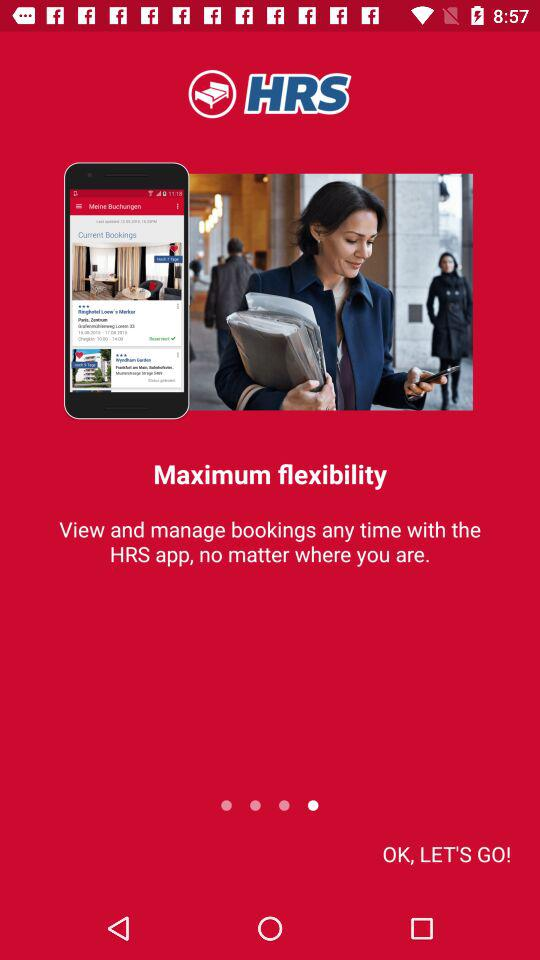What is the application name? The application name is "HRS". 